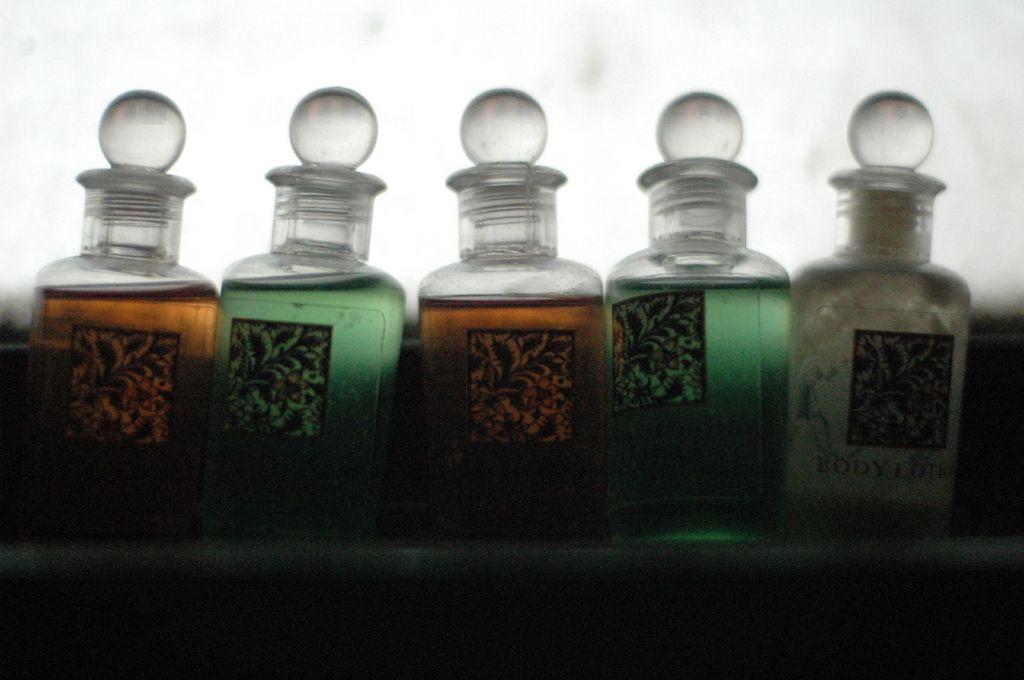What kind of product is the container on the far right?
Make the answer very short. Body lotion. 